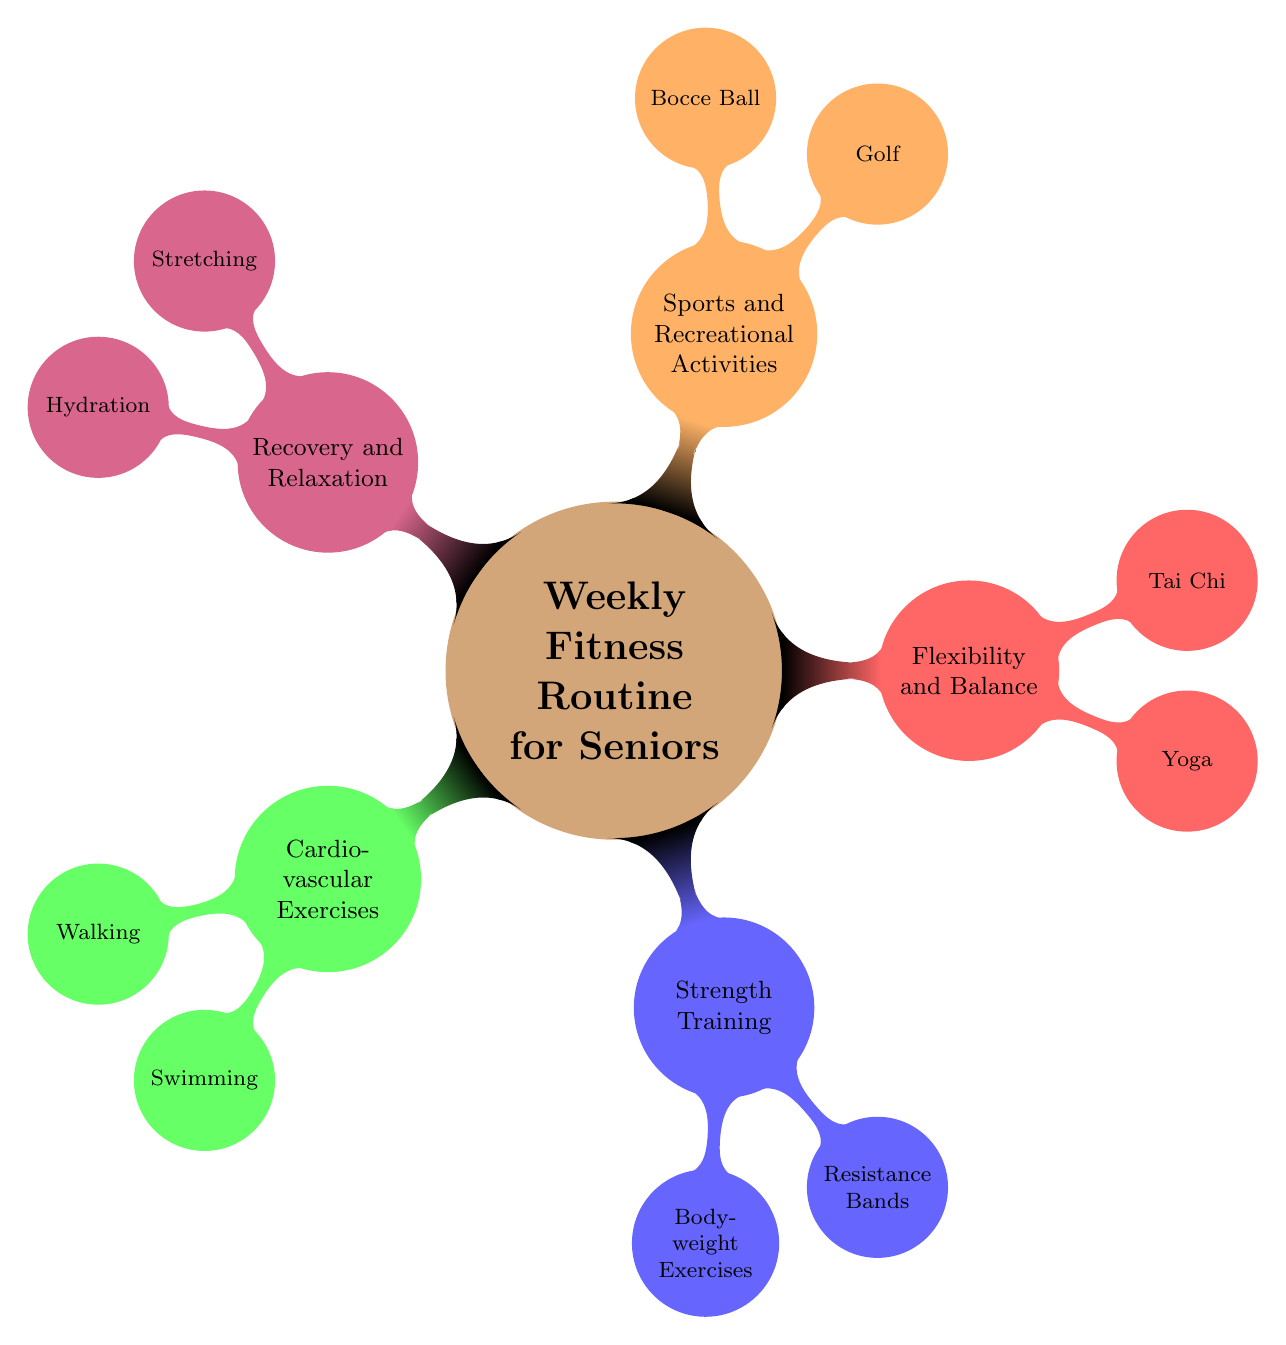What are the two types of exercises listed under Cardiovascular Exercises? By looking at the node for Cardiovascular Exercises, I see two child nodes underneath it, which are Walking and Swimming.
Answer: Walking, Swimming How many sets of Bodyweight Exercises are recommended? The node for Bodyweight Exercises states that 2 sets of 10 reps are recommended, which is indicated directly in the description.
Answer: 2 sets Which activity is suggested for flexibility and balance? The node for Flexibility and Balance has two child nodes, one of which is Yoga. This indicates that Yoga is among the recommended activities for this area.
Answer: Yoga What is the frequency of Tai Chi sessions in a week? Looking at the Tai Chi node, it indicates that it is suggested to be practiced twice a week. This information is specific within the description.
Answer: Twice a week What is the recommended duration for the Walking exercise? The Walking node specifically notes a duration of 30 minutes for this exercise, which is clearly stated in the description.
Answer: 30 minutes Which activity involves casual games and how often is it recommended? The Bocce Ball node clearly states that it involves casual games and is recommended twice a week, as denoted in the child node.
Answer: Twice a week What type of training is included under Strength Training? The Strength Training node has two specific child nodes that indicate the types of training: Bodyweight Exercises and Resistance Bands.
Answer: Bodyweight Exercises, Resistance Bands What is the main focus of the Recovery and Relaxation section? The Recovery and Relaxation section has two nodes, Stretching and Hydration, that both contribute to recovery and relaxation practices.
Answer: Stretching, Hydration 